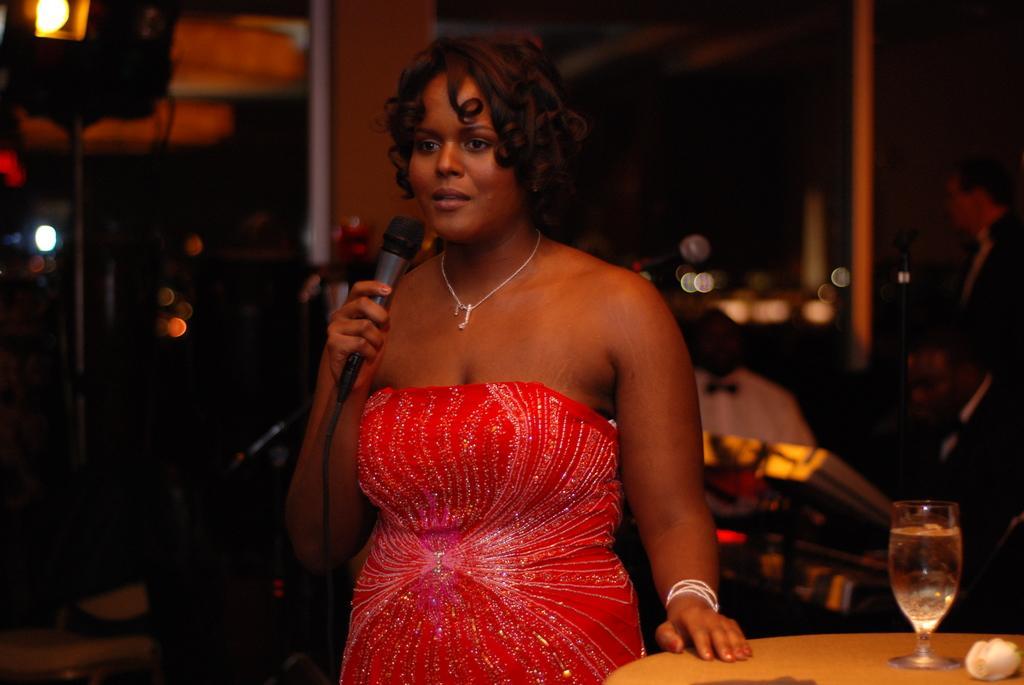How would you summarize this image in a sentence or two? in the picture lady is holding a mic wearing a red color dress beside her there is a table and a wine glass in the back ground it seems like a bar. 